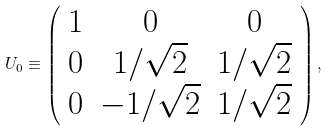<formula> <loc_0><loc_0><loc_500><loc_500>U _ { 0 } \equiv \left ( \begin{array} { c c c } 1 & 0 & 0 \\ 0 & 1 / \sqrt { 2 } & 1 / \sqrt { 2 } \\ 0 & - 1 / \sqrt { 2 } & 1 / \sqrt { 2 } \end{array} \right ) ,</formula> 